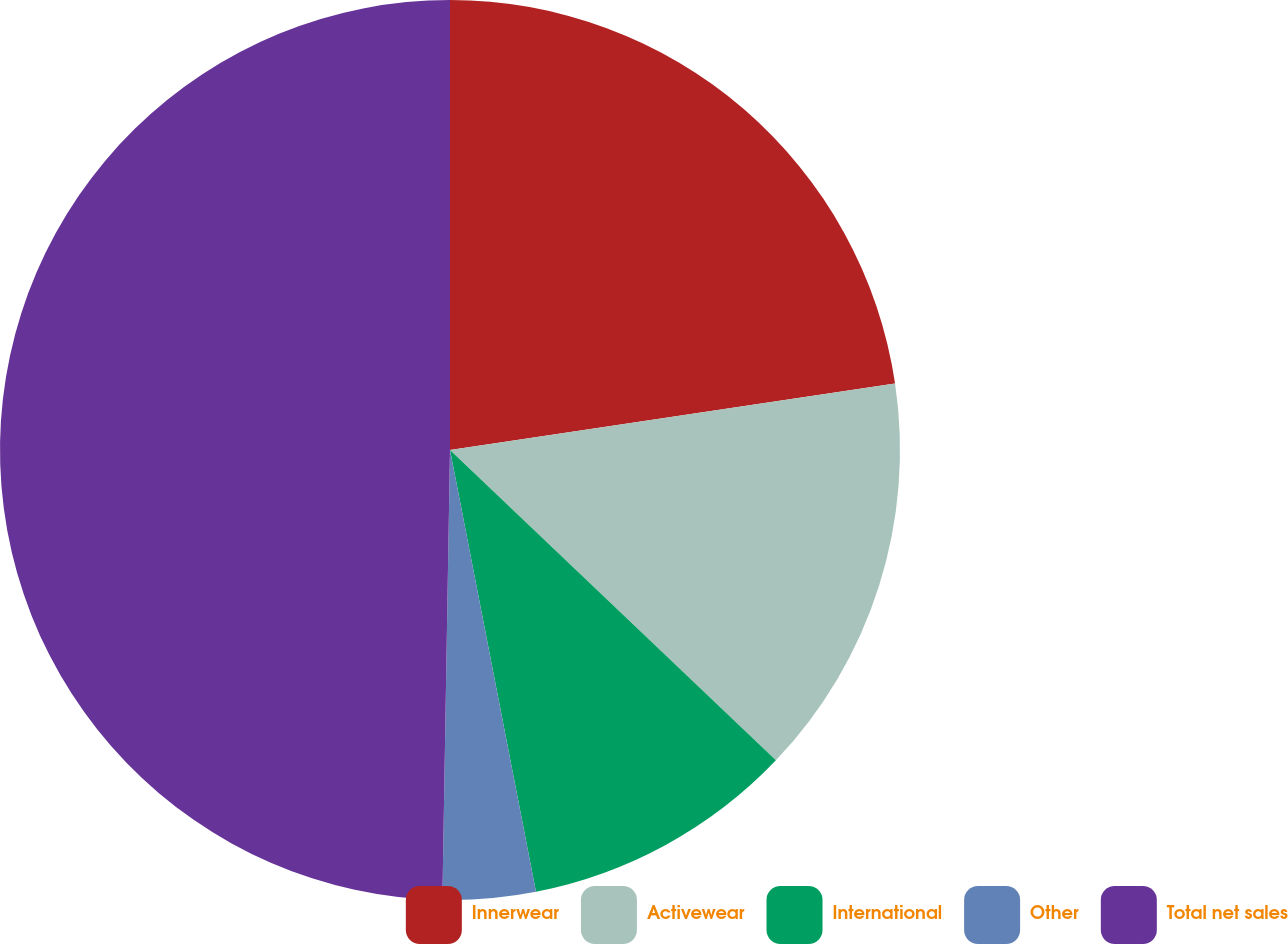<chart> <loc_0><loc_0><loc_500><loc_500><pie_chart><fcel>Innerwear<fcel>Activewear<fcel>International<fcel>Other<fcel>Total net sales<nl><fcel>22.64%<fcel>14.47%<fcel>9.83%<fcel>3.33%<fcel>49.73%<nl></chart> 